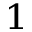<formula> <loc_0><loc_0><loc_500><loc_500>^ { 1 }</formula> 